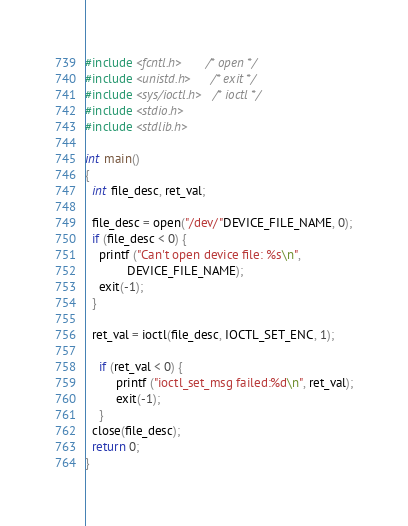Convert code to text. <code><loc_0><loc_0><loc_500><loc_500><_C_>#include <fcntl.h>      /* open */ 
#include <unistd.h>     /* exit */
#include <sys/ioctl.h>  /* ioctl */
#include <stdio.h>
#include <stdlib.h>

int main()
{
  int file_desc, ret_val;

  file_desc = open("/dev/"DEVICE_FILE_NAME, 0);
  if (file_desc < 0) {
    printf ("Can't open device file: %s\n", 
            DEVICE_FILE_NAME);
    exit(-1);
  }

  ret_val = ioctl(file_desc, IOCTL_SET_ENC, 1);

	if (ret_val < 0) {
	     printf ("ioctl_set_msg failed:%d\n", ret_val);
	     exit(-1);
	}	 
  close(file_desc); 
  return 0;
}
</code> 